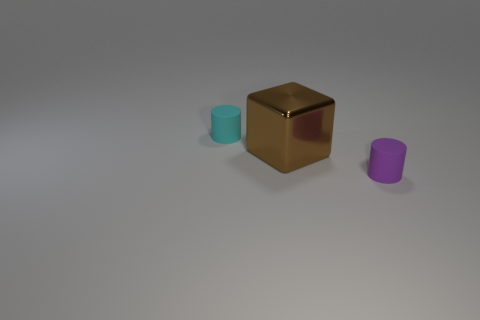There is a cube; is its color the same as the tiny cylinder that is to the right of the cyan matte object? no 